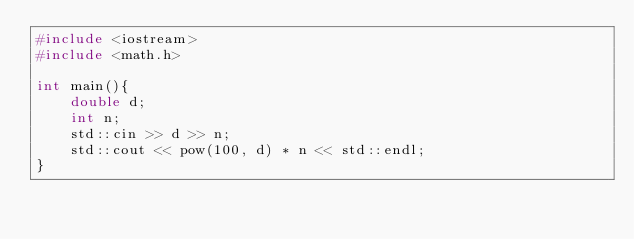<code> <loc_0><loc_0><loc_500><loc_500><_C++_>#include <iostream>
#include <math.h>

int main(){
    double d;
    int n;
    std::cin >> d >> n;
    std::cout << pow(100, d) * n << std::endl;
}
</code> 